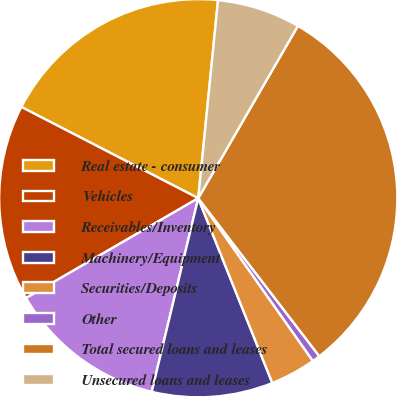Convert chart to OTSL. <chart><loc_0><loc_0><loc_500><loc_500><pie_chart><fcel>Real estate - consumer<fcel>Vehicles<fcel>Receivables/Inventory<fcel>Machinery/Equipment<fcel>Securities/Deposits<fcel>Other<fcel>Total secured loans and leases<fcel>Unsecured loans and leases<nl><fcel>19.0%<fcel>15.94%<fcel>12.88%<fcel>9.82%<fcel>3.7%<fcel>0.64%<fcel>31.24%<fcel>6.76%<nl></chart> 